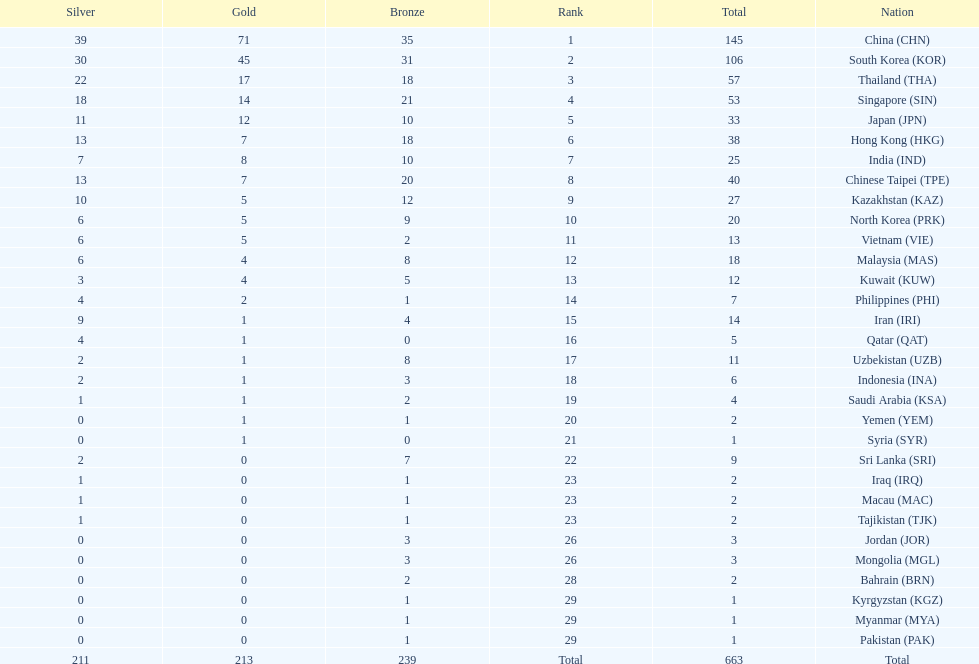What is the difference between the total amount of medals won by qatar and indonesia? 1. 